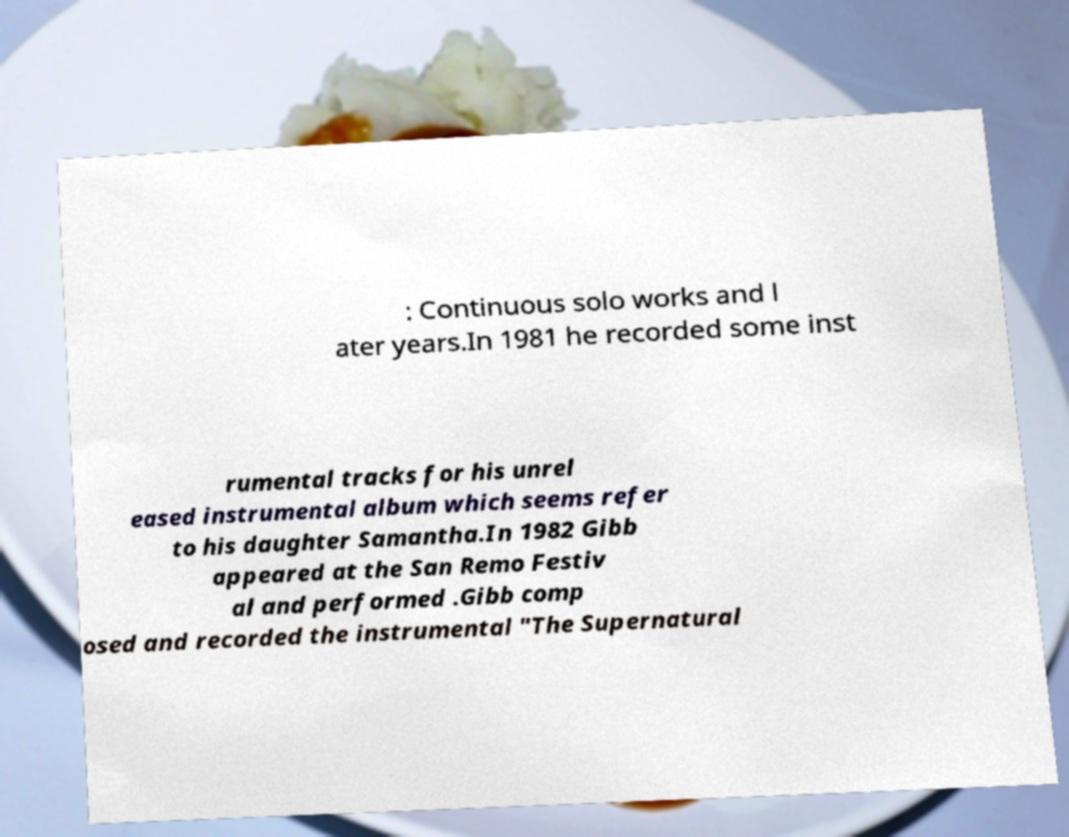Please read and relay the text visible in this image. What does it say? : Continuous solo works and l ater years.In 1981 he recorded some inst rumental tracks for his unrel eased instrumental album which seems refer to his daughter Samantha.In 1982 Gibb appeared at the San Remo Festiv al and performed .Gibb comp osed and recorded the instrumental "The Supernatural 